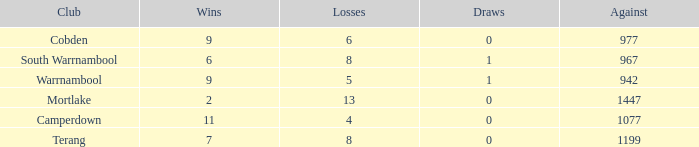What's the number of losses when the wins were more than 11 and had 0 draws? 0.0. 